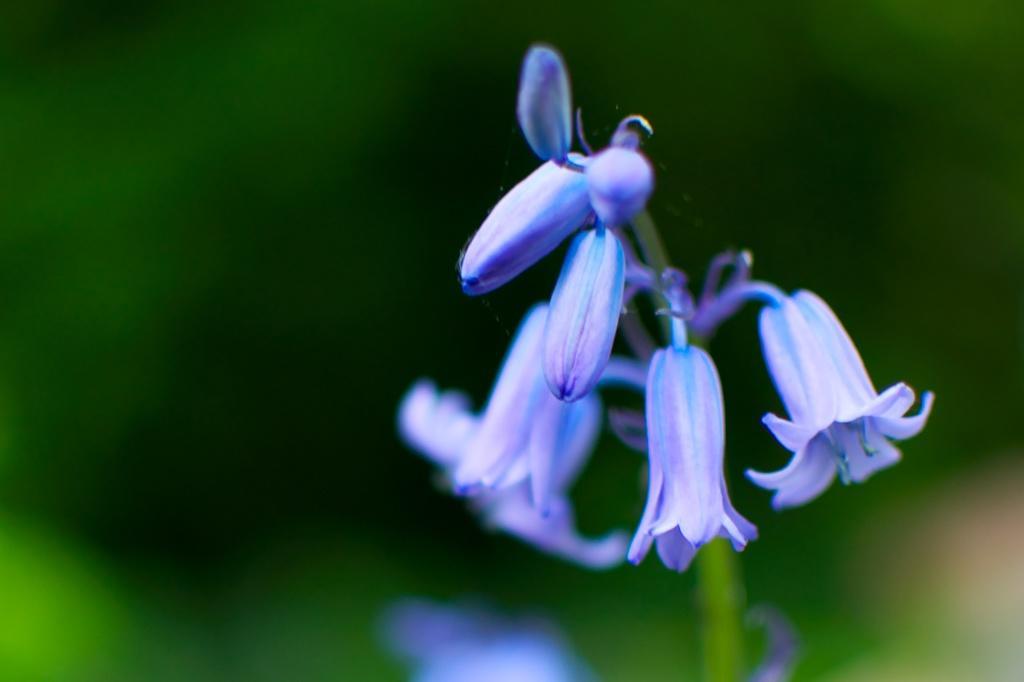Please provide a concise description of this image. In this image we can see flowers and buds to a plant. 